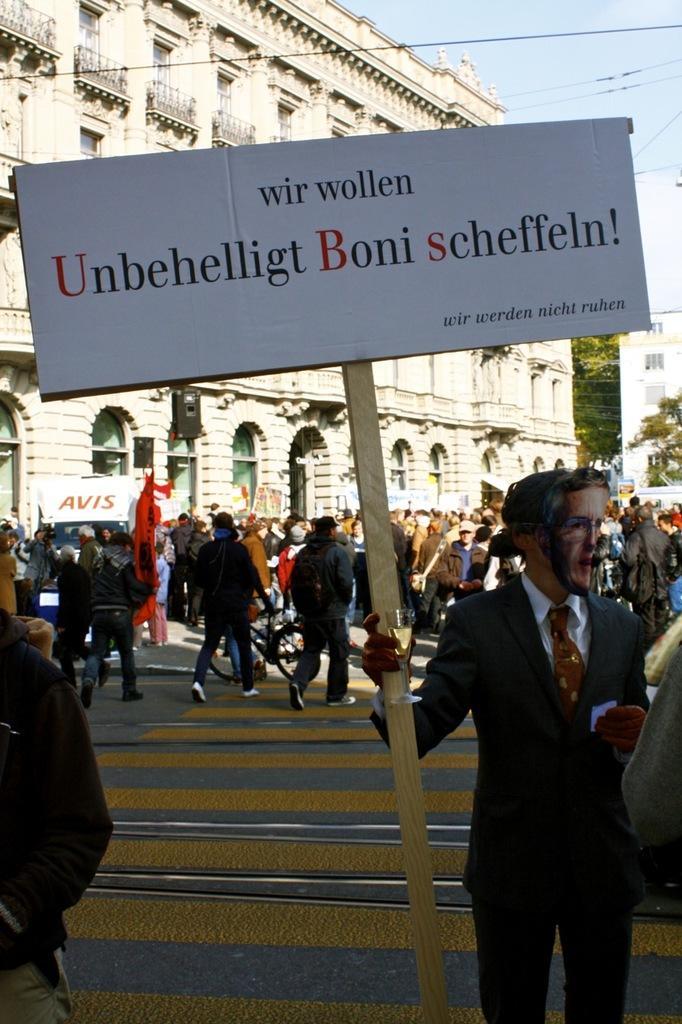In one or two sentences, can you explain what this image depicts? On the right side there is a person wearing mask and gloves is holding a placard. In the back there are many people. Also there is a road and a building with windows and arches. In the background there is sky. 